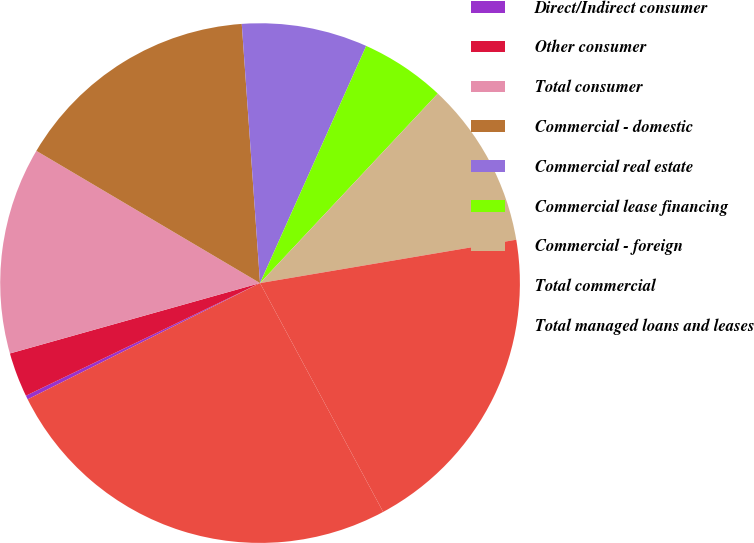Convert chart to OTSL. <chart><loc_0><loc_0><loc_500><loc_500><pie_chart><fcel>Direct/Indirect consumer<fcel>Other consumer<fcel>Total consumer<fcel>Commercial - domestic<fcel>Commercial real estate<fcel>Commercial lease financing<fcel>Commercial - foreign<fcel>Total commercial<fcel>Total managed loans and leases<nl><fcel>0.25%<fcel>2.77%<fcel>12.86%<fcel>15.38%<fcel>7.82%<fcel>5.29%<fcel>10.34%<fcel>19.81%<fcel>25.47%<nl></chart> 